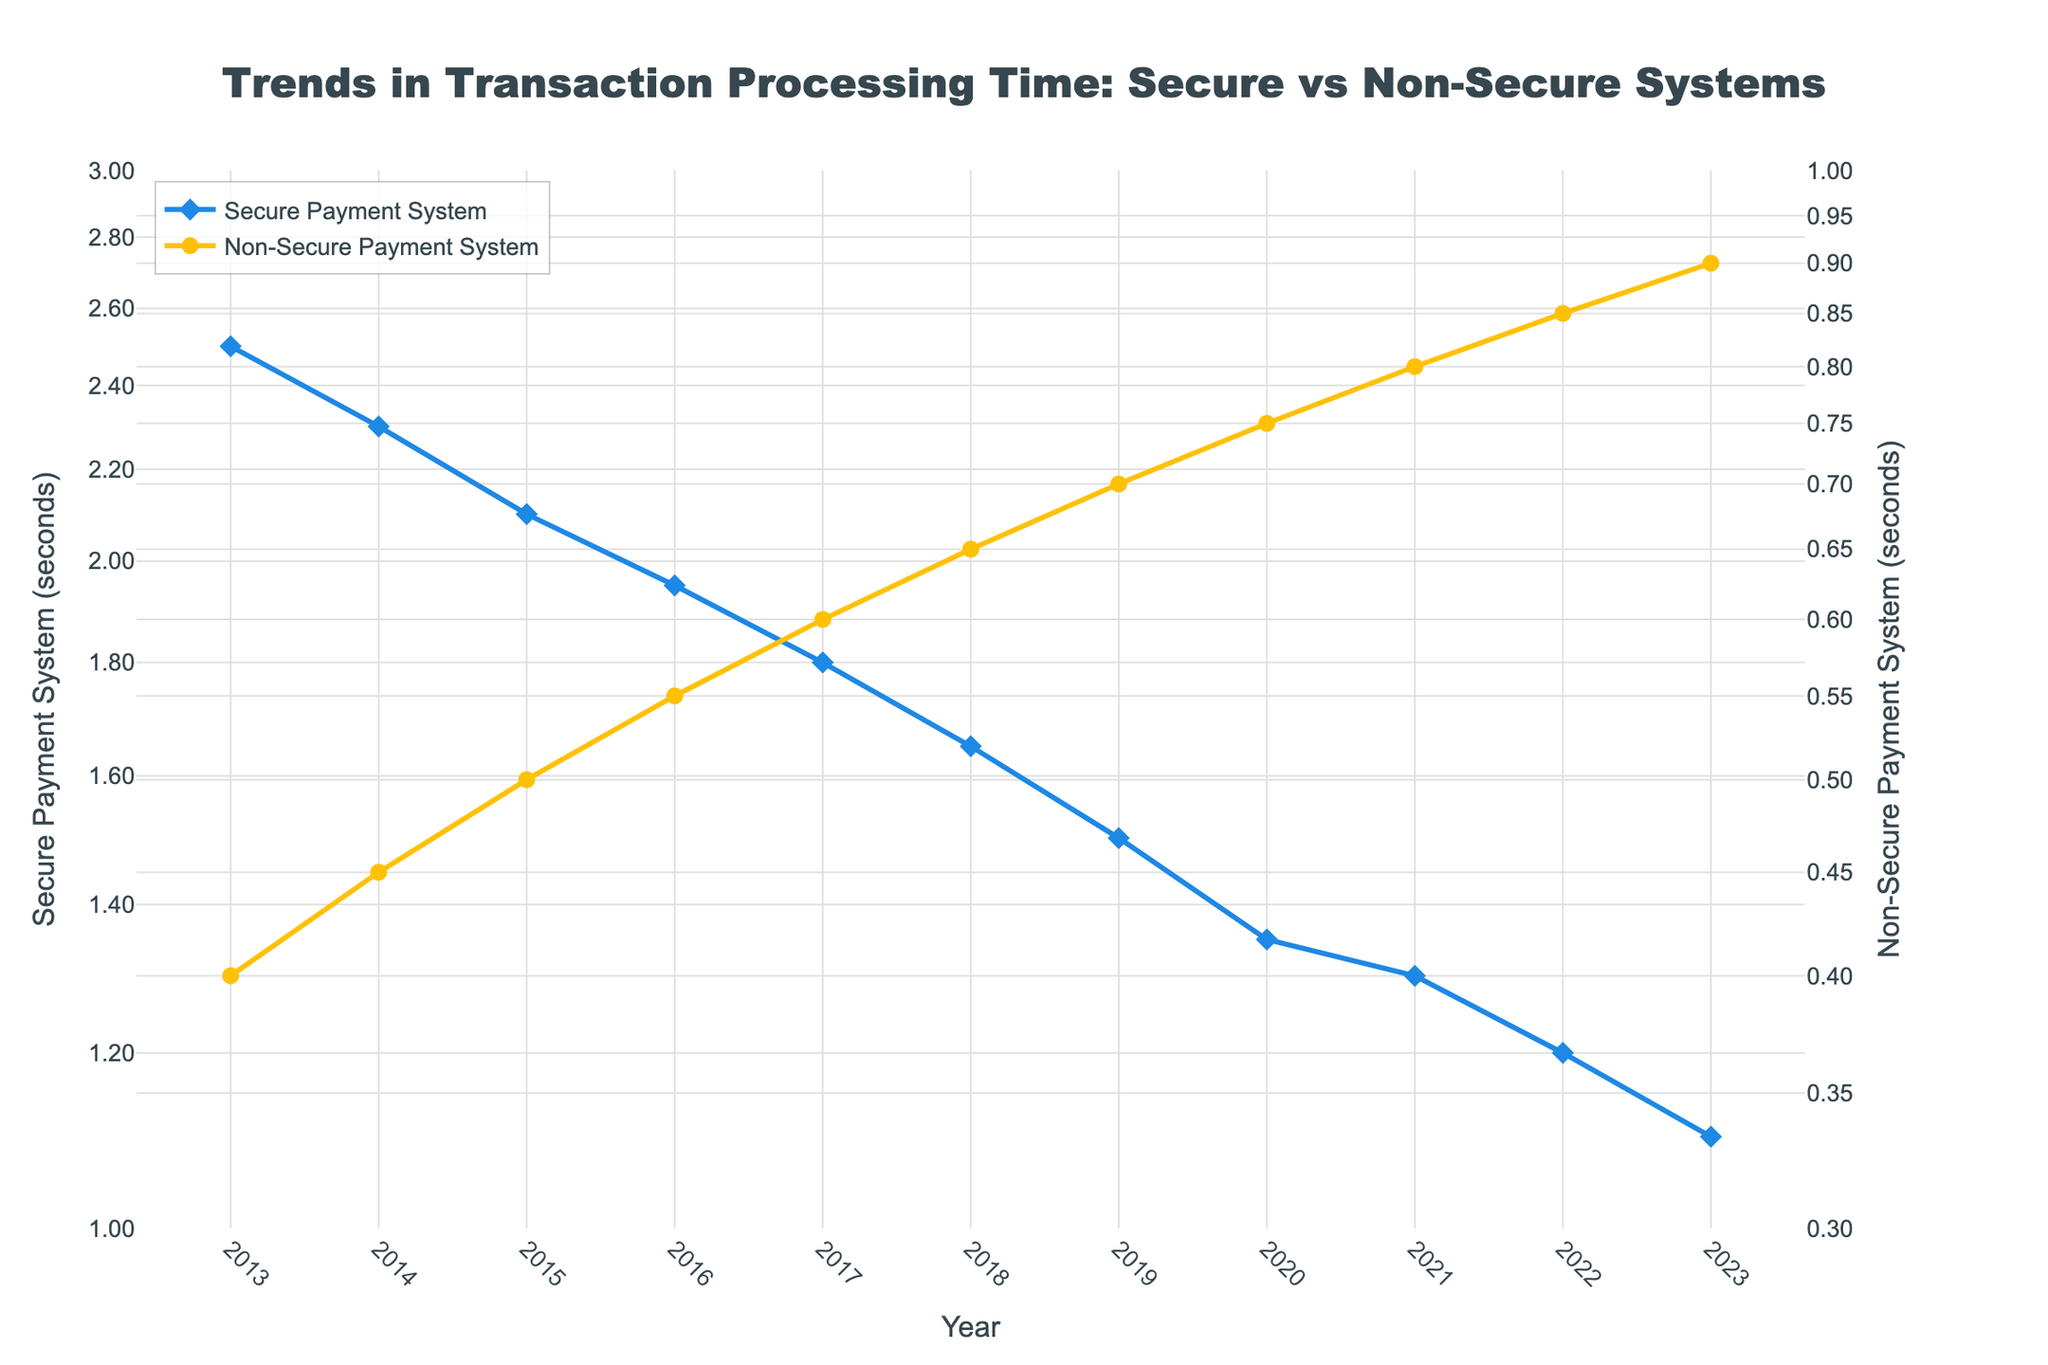How many years are tracked in this figure? The x-axis of the plot lists the years from 2013 to 2023. Counting all these years, we find there are 11 years tracked in the figure.
Answer: 11 What is the overall trend in processing time for non-secure payment systems over the last 10 years? Observing the yellow line representing non-secure payment systems, it shows a steady increase in transaction processing time from 0.4 seconds in 2013 to 0.9 seconds in 2023.
Answer: Increasing How do the processing times for secure and non-secure payment systems compare in 2017? In 2017, the processing time for the secure payment system is approximately 1.8 seconds (blue line), while for the non-secure payment system, it is around 0.6 seconds (yellow line).
Answer: Secure: 1.8 seconds, Non-secure: 0.6 seconds By how much did the processing time for secure payment systems decrease from 2013 to 2023? In 2013, the processing time for the secure payment system was 2.5 seconds and in 2023 it was 1.1 seconds. The difference is 2.5 - 1.1 = 1.4 seconds.
Answer: 1.4 seconds What is the rate of change in processing time for non-secure payment systems from 2013 to 2023? The processing time for non-secure payment systems increased from 0.4 seconds in 2013 to 0.9 seconds in 2023. The rate of change is (0.9 - 0.4) / 10 years = 0.05 seconds per year.
Answer: 0.05 seconds per year Which system shows a more significant improvement over the 10 year period? The secure payment system decreased from 2.5 seconds in 2013 to 1.1 seconds in 2023, while the non-secure payment system only increased from 0.4 to 0.9 seconds. The magnitude of change is more significant for the secure system.
Answer: Secure payment system What was the processing time for non-secure payment systems in 2021, and how does it compare to that of secure payment systems in the same year? In 2021, the non-secure payment system had a processing time of 0.8 seconds, whereas the secure payment system had a processing time of 1.3 seconds. The secure system's processing time was higher.
Answer: Non-secure: 0.8 seconds, Secure: 1.3 seconds How can one describe the trend of secure payment system processing time using the y-axis log scale? The log scale helps to visualize the relative rate of decrease in processing times more clearly. The secure payment system shows a near exponential decrease in processing times over the years, as evidenced by the evenly spaced reduction on the log scale.
Answer: Near exponential decrease In which year did the secure payment system processing time first drop below 2 seconds? The secure payment system processing time dropped below 2 seconds for the first time in 2016, as observed from the blue line on the graph.
Answer: 2016 